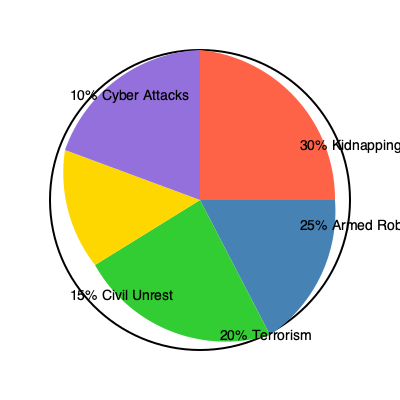Based on the pie chart showing common security threats in hostile environments, which two threats combined account for more than half of all security concerns? To answer this question, we need to analyze the percentages given for each security threat in the pie chart:

1. Kidnapping: 30%
2. Armed Robbery: 25%
3. Terrorism: 20%
4. Civil Unrest: 15%
5. Cyber Attacks: 10%

To find two threats that account for more than 50% of all security concerns, we need to add the percentages of different combinations until we find a sum greater than 50%.

The largest slice is Kidnapping at 30%, so let's start with that:

1. Kidnapping (30%) + Armed Robbery (25%) = 55%

This combination already exceeds 50%, so we don't need to check any other combinations.

Therefore, Kidnapping and Armed Robbery combined account for 55% of all security concerns, which is more than half.
Answer: Kidnapping and Armed Robbery 